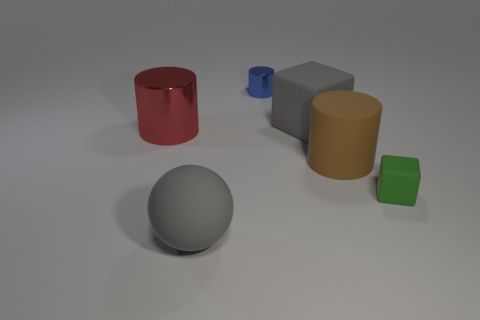There is a big cylinder that is to the left of the gray rubber ball; does it have the same color as the small cube?
Offer a terse response. No. Are there the same number of balls that are behind the large brown rubber thing and big gray rubber blocks that are to the left of the tiny blue shiny object?
Offer a terse response. Yes. Are there any other things that have the same material as the large red object?
Your answer should be compact. Yes. There is a rubber thing that is behind the red cylinder; what is its color?
Your response must be concise. Gray. Are there an equal number of large gray matte objects that are in front of the large metal cylinder and red matte cylinders?
Provide a short and direct response. No. How many other objects are there of the same shape as the big red object?
Your response must be concise. 2. What number of large red shiny objects are behind the large gray cube?
Offer a very short reply. 0. There is a thing that is both in front of the brown object and right of the big matte ball; what size is it?
Your response must be concise. Small. Is there a large metal thing?
Your response must be concise. Yes. How many other things are there of the same size as the blue cylinder?
Give a very brief answer. 1. 